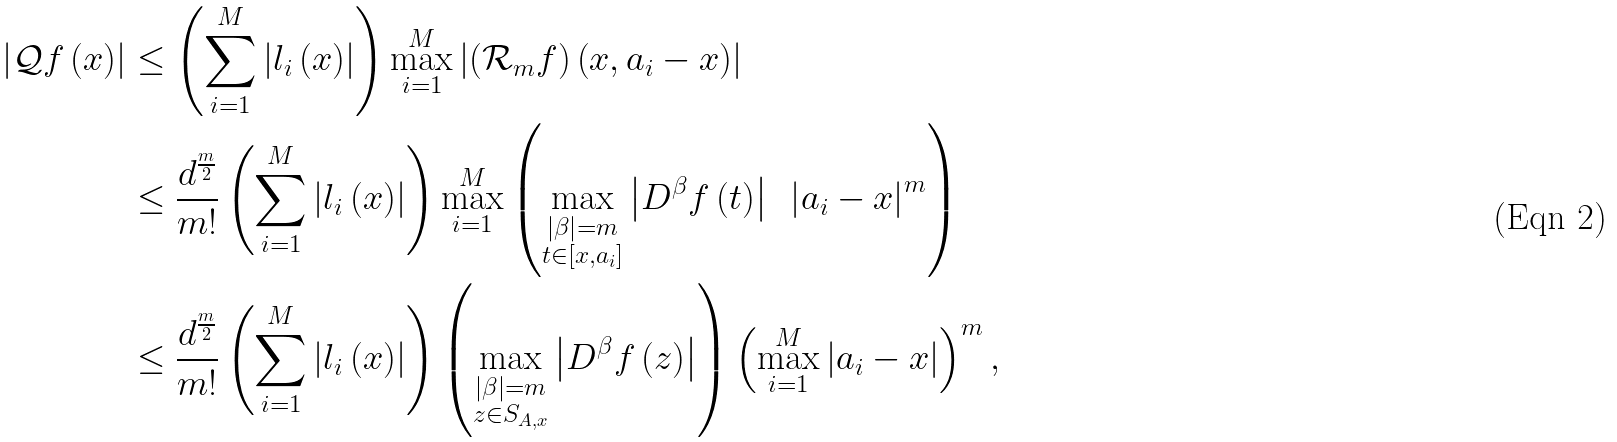<formula> <loc_0><loc_0><loc_500><loc_500>\left | \mathcal { Q } f \left ( x \right ) \right | & \leq \left ( \sum _ { i = 1 } ^ { M } \left | l _ { i } \left ( x \right ) \right | \right ) \max _ { i = 1 } ^ { M } \left | \left ( \mathcal { R } _ { m } f \right ) \left ( x , a _ { i } - x \right ) \right | \\ & \leq \frac { d ^ { \frac { m } { 2 } } } { m ! } \left ( \sum _ { i = 1 } ^ { M } \left | l _ { i } \left ( x \right ) \right | \right ) \max _ { i = 1 } ^ { M } \left ( \max _ { \substack { \left | \beta \right | = m \\ t \in \left [ x , a _ { i } \right ] } } \left | D ^ { \beta } f \left ( t \right ) \right | \text { } \left | a _ { i } - x \right | ^ { m } \right ) \\ & \leq \frac { d ^ { \frac { m } { 2 } } } { m ! } \left ( \sum _ { i = 1 } ^ { M } \left | l _ { i } \left ( x \right ) \right | \right ) \left ( \max _ { \substack { \left | \beta \right | = m \\ z \in S _ { A , x } } } \left | D ^ { \beta } f \left ( z \right ) \right | \right ) \left ( \max _ { i = 1 } ^ { M } \left | a _ { i } - x \right | \right ) ^ { m } ,</formula> 